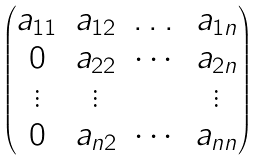Convert formula to latex. <formula><loc_0><loc_0><loc_500><loc_500>\begin{pmatrix} a _ { 1 1 } & a _ { 1 2 } & \dots & a _ { 1 n } \\ 0 & a _ { 2 2 } & \cdots & a _ { 2 n } \\ \vdots & \vdots & & \vdots \\ 0 & a _ { n 2 } & \cdots & a _ { n n } \end{pmatrix}</formula> 